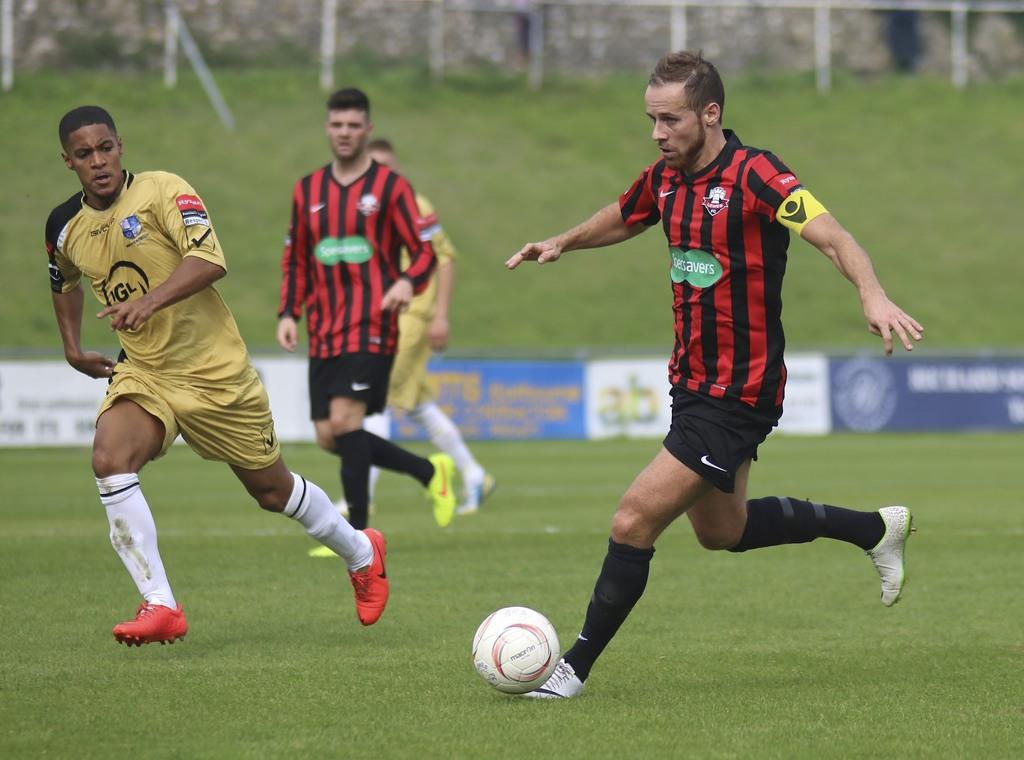How many people are in the image? There are four persons in the image. What are the persons doing in the image? The persons are running on a ball. Where is the ball located? The ball is on the grass. What can be seen in the background of the image? There are banners and a fence in the background of the image. What type of thumb is visible in the image? There is no thumb present in the image. What is the behavior of the persons in the image? The persons are running on a ball, which indicates they are engaged in a physical activity and possibly participating in a game or event. 